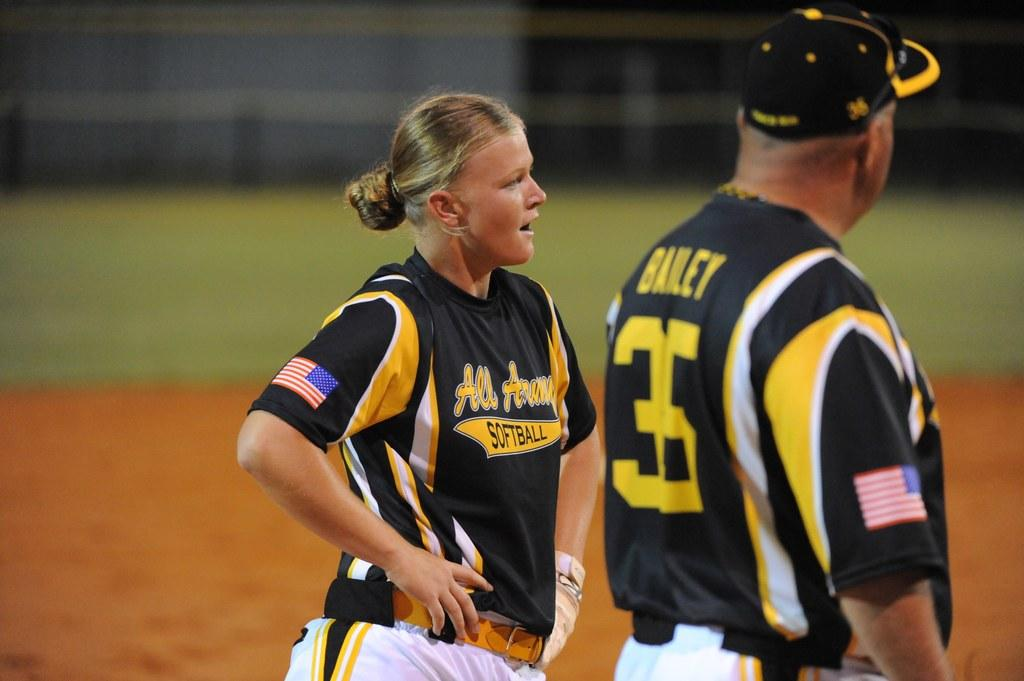Provide a one-sentence caption for the provided image. The man on the right has the number 35 on his jersey. 